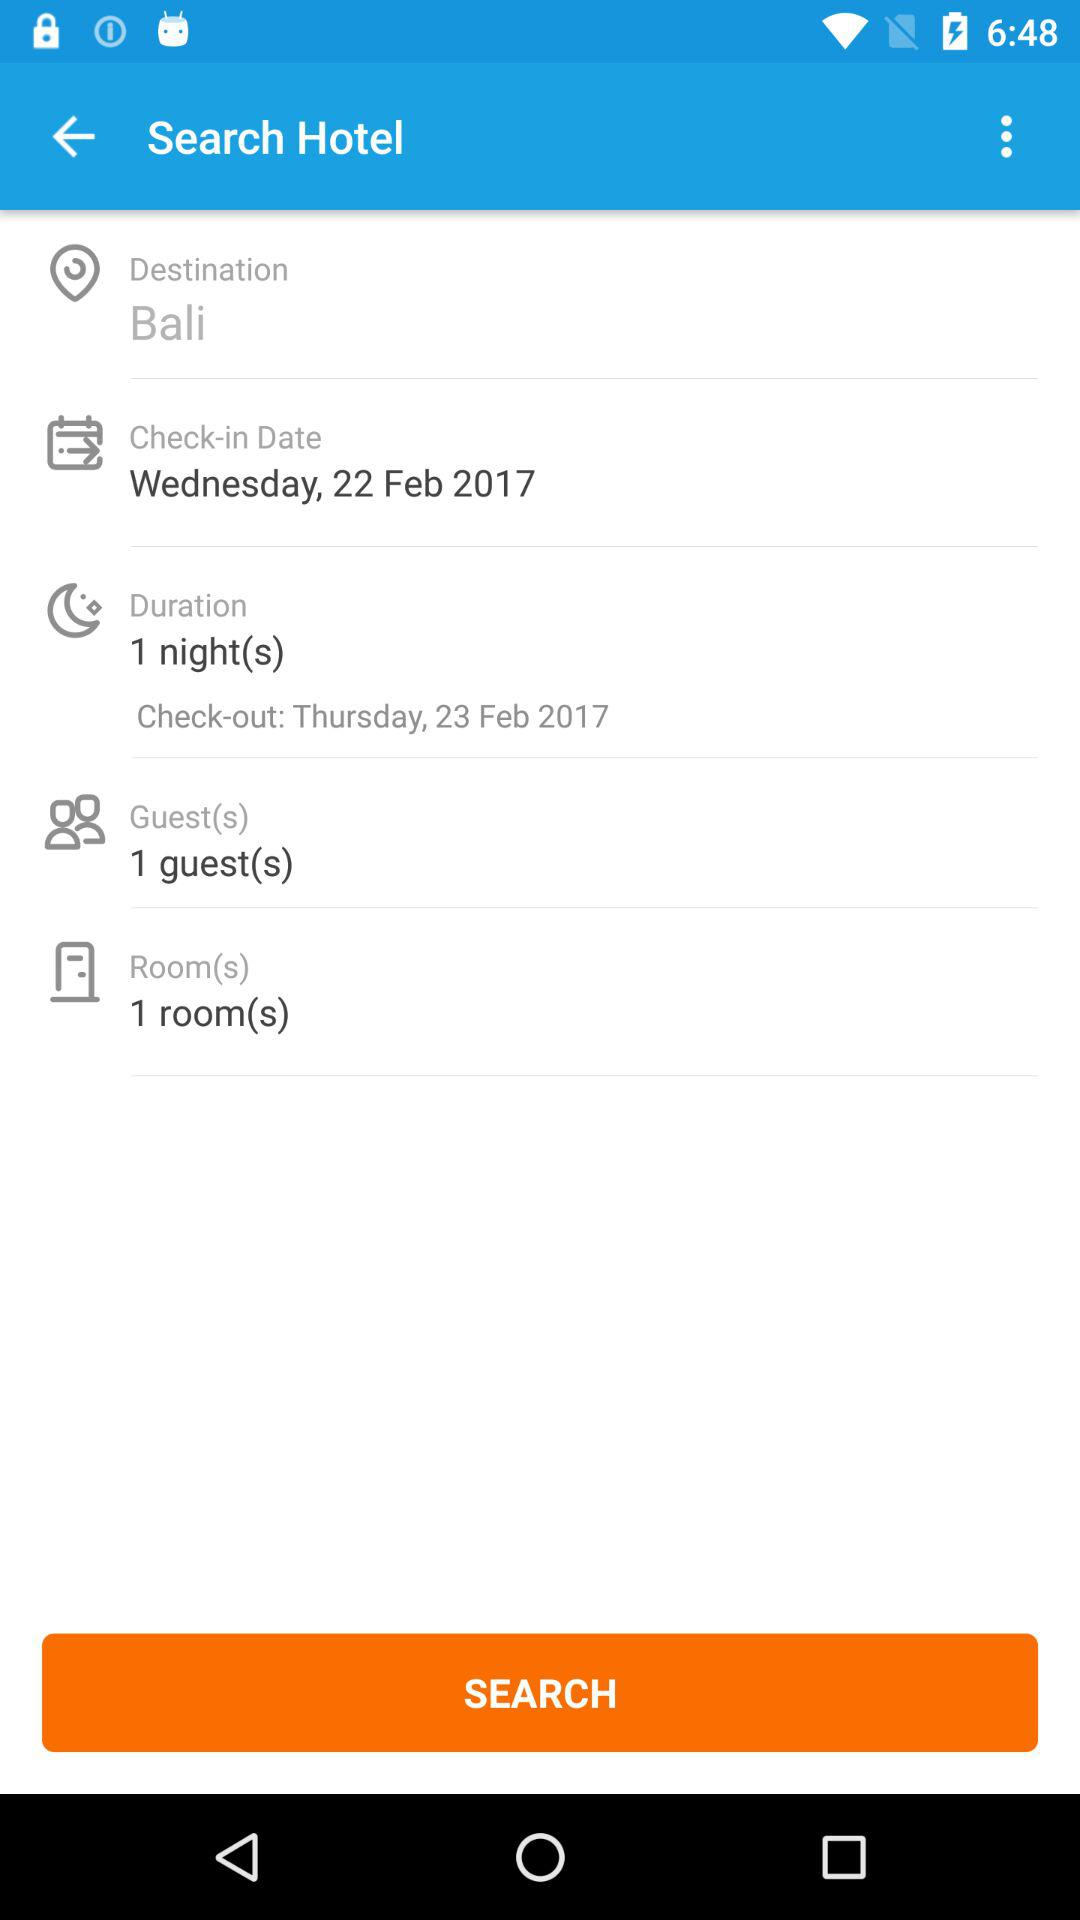What is the check-in date? The check-in date is Wednesday, February 22, 2017. 